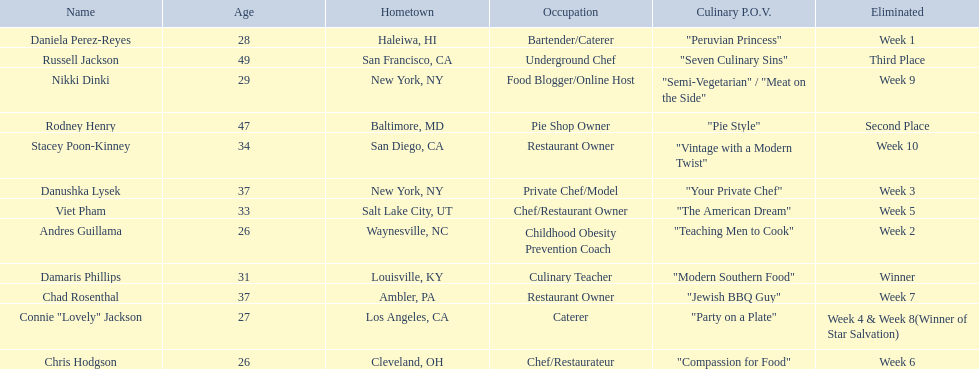Who are the  food network stars? Damaris Phillips, Rodney Henry, Russell Jackson, Stacey Poon-Kinney, Nikki Dinki, Chad Rosenthal, Chris Hodgson, Viet Pham, Connie "Lovely" Jackson, Danushka Lysek, Andres Guillama, Daniela Perez-Reyes. When did nikki dinki get eliminated? Week 9. When did viet pham get eliminated? Week 5. Which week came first? Week 5. Who was it that was eliminated week 5? Viet Pham. 